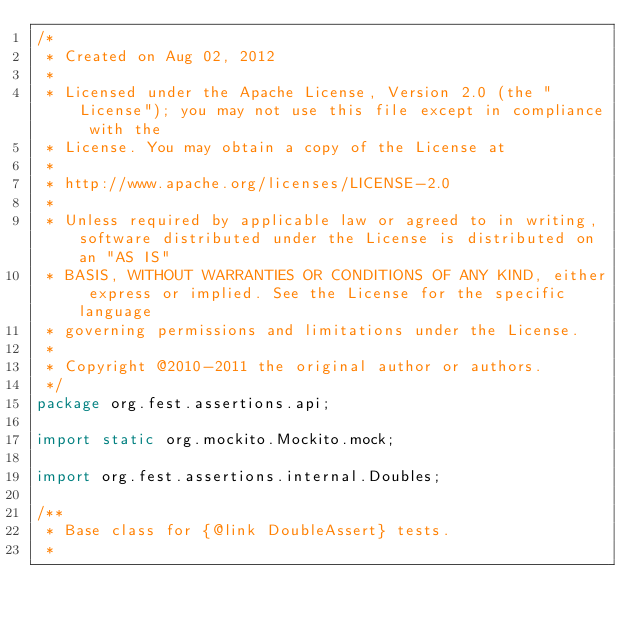Convert code to text. <code><loc_0><loc_0><loc_500><loc_500><_Java_>/*
 * Created on Aug 02, 2012
 * 
 * Licensed under the Apache License, Version 2.0 (the "License"); you may not use this file except in compliance with the
 * License. You may obtain a copy of the License at
 * 
 * http://www.apache.org/licenses/LICENSE-2.0
 * 
 * Unless required by applicable law or agreed to in writing, software distributed under the License is distributed on an "AS IS"
 * BASIS, WITHOUT WARRANTIES OR CONDITIONS OF ANY KIND, either express or implied. See the License for the specific language
 * governing permissions and limitations under the License.
 * 
 * Copyright @2010-2011 the original author or authors.
 */
package org.fest.assertions.api;

import static org.mockito.Mockito.mock;

import org.fest.assertions.internal.Doubles;

/**
 * Base class for {@link DoubleAssert} tests.
 * </code> 